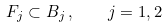Convert formula to latex. <formula><loc_0><loc_0><loc_500><loc_500>F _ { j } \subset B _ { j } \, , \quad j = 1 , 2</formula> 